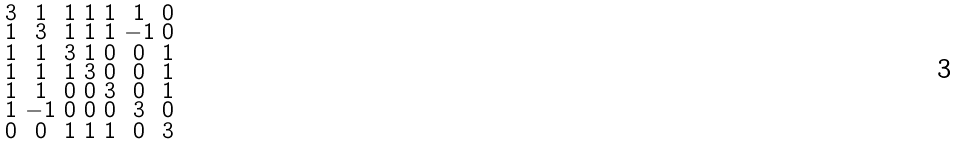<formula> <loc_0><loc_0><loc_500><loc_500>\begin{smallmatrix} 3 & 1 & 1 & 1 & 1 & 1 & 0 \\ 1 & 3 & 1 & 1 & 1 & - 1 & 0 \\ 1 & 1 & 3 & 1 & 0 & 0 & 1 \\ 1 & 1 & 1 & 3 & 0 & 0 & 1 \\ 1 & 1 & 0 & 0 & 3 & 0 & 1 \\ 1 & - 1 & 0 & 0 & 0 & 3 & 0 \\ 0 & 0 & 1 & 1 & 1 & 0 & 3 \end{smallmatrix}</formula> 